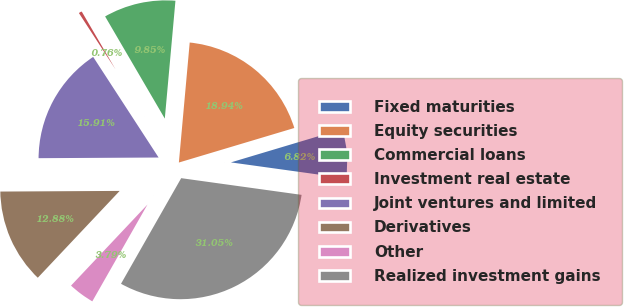Convert chart to OTSL. <chart><loc_0><loc_0><loc_500><loc_500><pie_chart><fcel>Fixed maturities<fcel>Equity securities<fcel>Commercial loans<fcel>Investment real estate<fcel>Joint ventures and limited<fcel>Derivatives<fcel>Other<fcel>Realized investment gains<nl><fcel>6.82%<fcel>18.94%<fcel>9.85%<fcel>0.76%<fcel>15.91%<fcel>12.88%<fcel>3.79%<fcel>31.05%<nl></chart> 